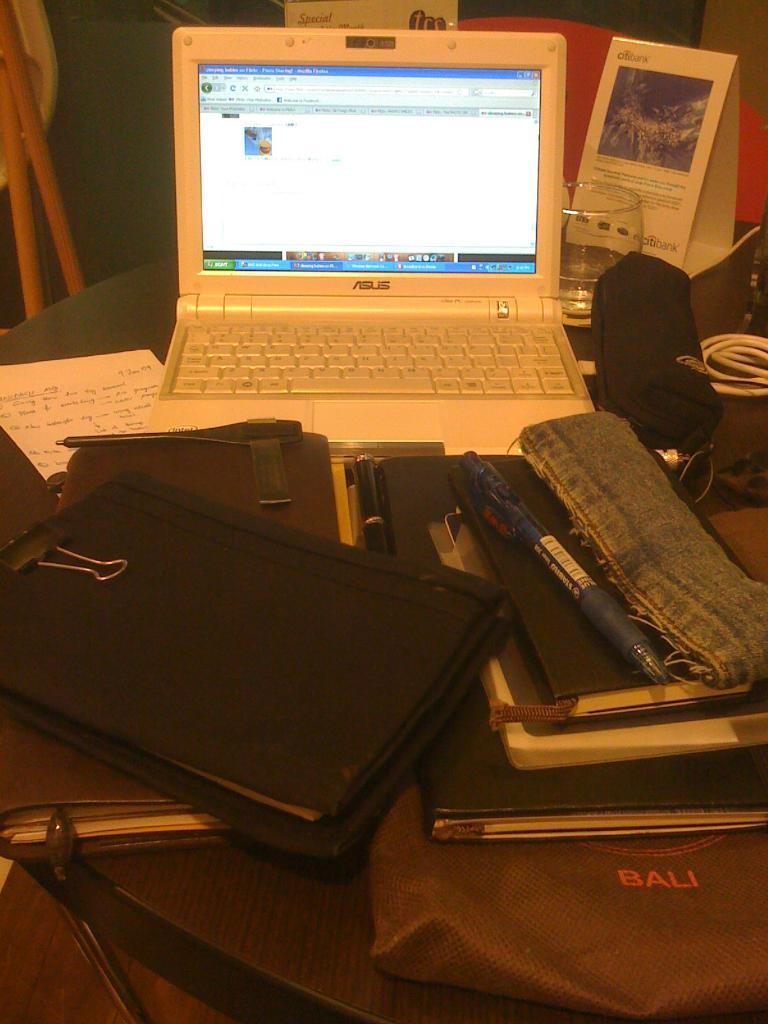<image>
Summarize the visual content of the image. A pile of notebooks and planners in front of a laptop on top of a bag that says Bali. 